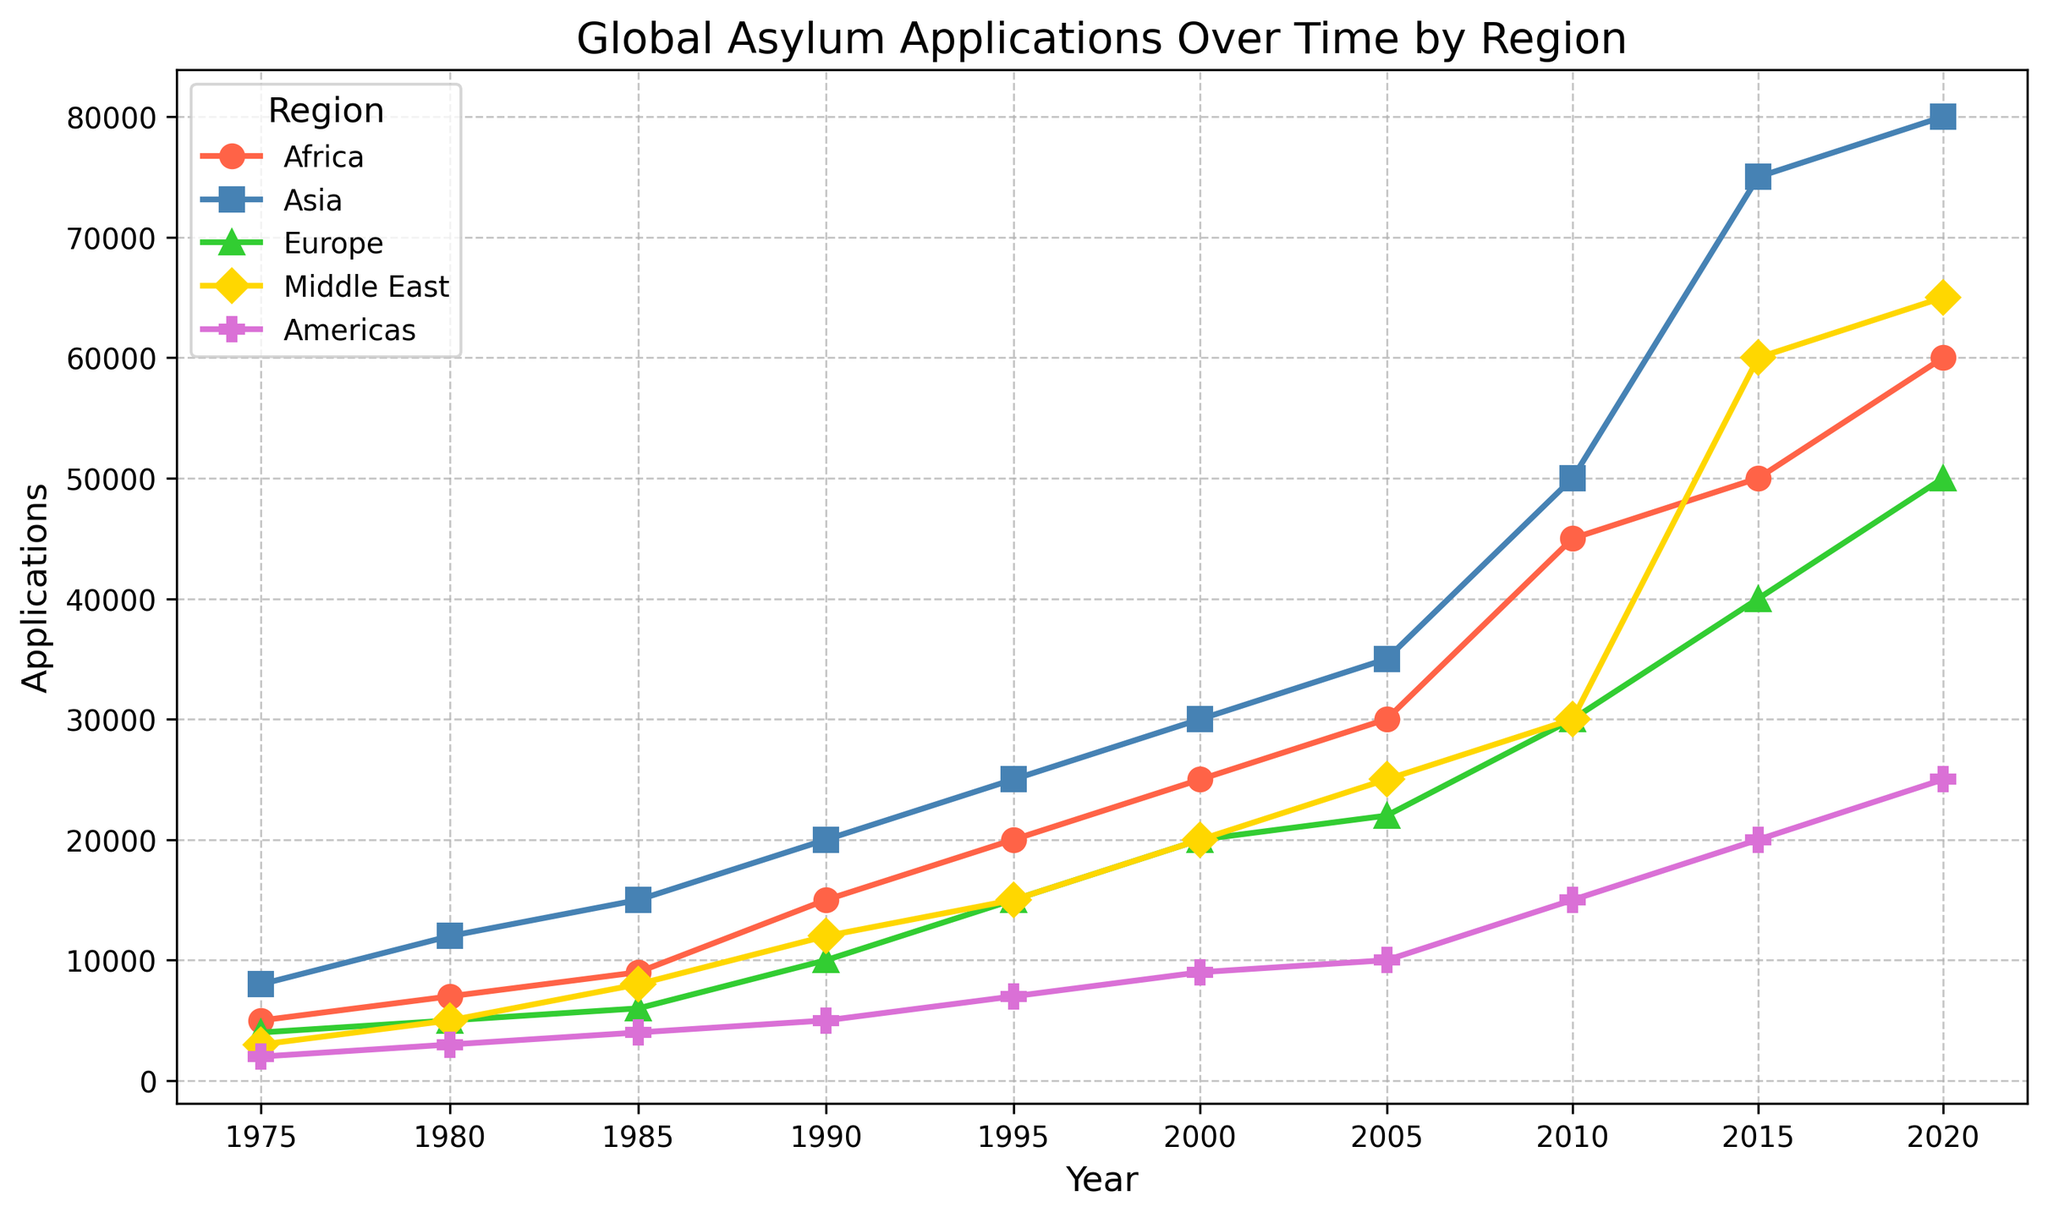What is the trend in asylum applications for Asia over the years? Looking at the figure, the asylum applications for Asia show a generally increasing trend from 1975 to 2020, with significant increases around 2005 and another jump between 2015 and 2020.
Answer: Increasing How does the number of asylum applications in Europe in 2020 compare to those in 2010? According to the figure, Europe had 50,000 asylum applications in 2020 and 30,000 in 2010. Comparing these values, there is an increase.
Answer: Increase Which region had the highest number of asylum applications in 2015, and what was the number? Referring to the figure, it is visible that Asia had the highest number of asylum applications in 2015 at 75,000 applications.
Answer: Asia, 75,000 How do the asylum applications in the Middle East differ between 1975 and 2020? The figure shows the Middle East had 3,000 applications in 1975 and 65,000 in 2020. This indicates a significant increase over this period.
Answer: Increased by 62,000 Which region had the lowest number of asylum applications in 2000? Based on the chart, the Americas had the lowest number of asylum applications in 2000 with 9,000 applications.
Answer: Americas What is the sum of the asylum applications for Africa and Asia in 1990? Referring to the figure, Africa had 15,000 applications and Asia had 20,000 applications in 1990. Adding these together gives 15,000 + 20,000 = 35,000.
Answer: 35,000 Which region saw the greatest increase in asylum applications from 1975 to 2020? By evaluating the figure, Asia shows the greatest increase from 8,000 in 1975 to 80,000 in 2020, an increase of 72,000.
Answer: Asia Compare the trends of asylum applications in the Americas and the Middle East from 1975 to 2020. Observing the figure, the applications in the Middle East increased dramatically from 3,000 in 1975 to 65,000 in 2020. In contrast, the Americas saw a more moderate increase from 2,000 in 1975 to 25,000 in 2020.
Answer: The Middle East saw a greater increase From 2005 to 2010, which region had the largest percentage increase in asylum applications? The figure shows that Africa increased from 30,000 in 2005 to 45,000 in 2010 (50% increase), while other regions had smaller percentage increases.
Answer: Africa 